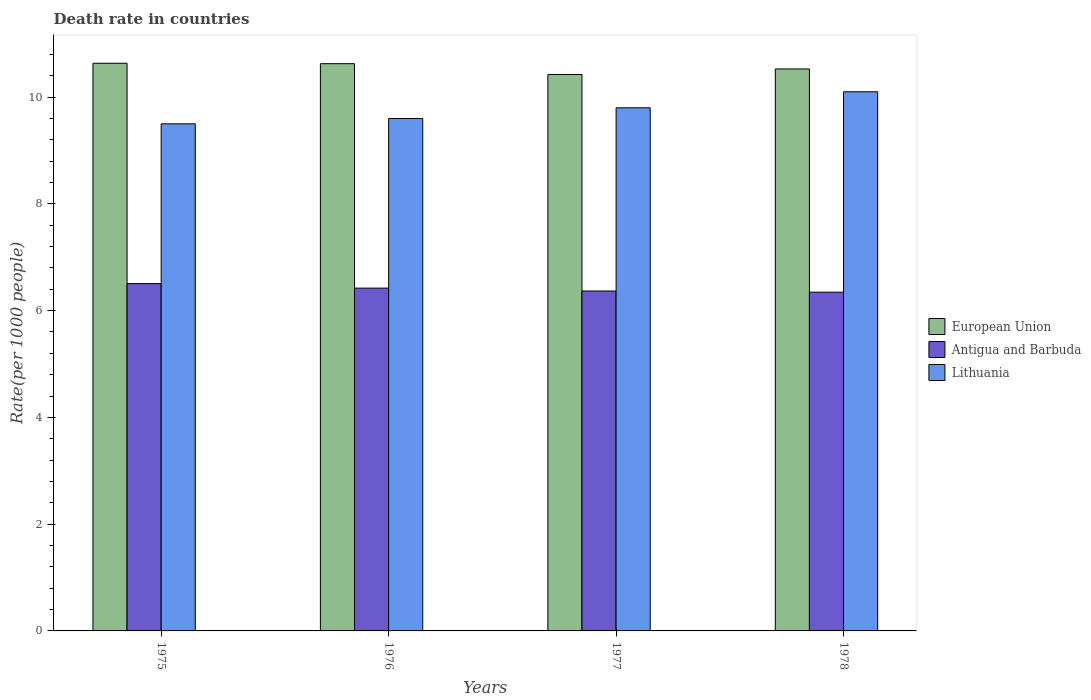How many groups of bars are there?
Provide a short and direct response. 4. Are the number of bars on each tick of the X-axis equal?
Keep it short and to the point. Yes. What is the label of the 4th group of bars from the left?
Provide a short and direct response. 1978. In how many cases, is the number of bars for a given year not equal to the number of legend labels?
Provide a short and direct response. 0. What is the death rate in Antigua and Barbuda in 1976?
Your response must be concise. 6.42. Across all years, what is the minimum death rate in Antigua and Barbuda?
Make the answer very short. 6.35. In which year was the death rate in Lithuania maximum?
Provide a short and direct response. 1978. In which year was the death rate in Lithuania minimum?
Make the answer very short. 1975. What is the total death rate in European Union in the graph?
Give a very brief answer. 42.21. What is the difference between the death rate in Antigua and Barbuda in 1976 and that in 1977?
Make the answer very short. 0.05. What is the difference between the death rate in Lithuania in 1976 and the death rate in Antigua and Barbuda in 1978?
Provide a succinct answer. 3.25. What is the average death rate in Lithuania per year?
Your answer should be compact. 9.75. In the year 1978, what is the difference between the death rate in Antigua and Barbuda and death rate in European Union?
Ensure brevity in your answer.  -4.18. In how many years, is the death rate in European Union greater than 8.8?
Keep it short and to the point. 4. What is the ratio of the death rate in European Union in 1975 to that in 1977?
Ensure brevity in your answer.  1.02. Is the death rate in European Union in 1976 less than that in 1977?
Provide a short and direct response. No. What is the difference between the highest and the second highest death rate in Lithuania?
Provide a succinct answer. 0.3. What is the difference between the highest and the lowest death rate in Lithuania?
Make the answer very short. 0.6. Is the sum of the death rate in Antigua and Barbuda in 1976 and 1978 greater than the maximum death rate in European Union across all years?
Make the answer very short. Yes. What does the 3rd bar from the left in 1977 represents?
Offer a very short reply. Lithuania. What does the 3rd bar from the right in 1976 represents?
Ensure brevity in your answer.  European Union. How many bars are there?
Give a very brief answer. 12. Are all the bars in the graph horizontal?
Offer a very short reply. No. How many years are there in the graph?
Provide a succinct answer. 4. What is the difference between two consecutive major ticks on the Y-axis?
Make the answer very short. 2. How many legend labels are there?
Your answer should be very brief. 3. How are the legend labels stacked?
Ensure brevity in your answer.  Vertical. What is the title of the graph?
Your answer should be very brief. Death rate in countries. Does "High income: nonOECD" appear as one of the legend labels in the graph?
Keep it short and to the point. No. What is the label or title of the X-axis?
Ensure brevity in your answer.  Years. What is the label or title of the Y-axis?
Your answer should be very brief. Rate(per 1000 people). What is the Rate(per 1000 people) in European Union in 1975?
Your answer should be compact. 10.63. What is the Rate(per 1000 people) of Antigua and Barbuda in 1975?
Ensure brevity in your answer.  6.51. What is the Rate(per 1000 people) of Lithuania in 1975?
Your response must be concise. 9.5. What is the Rate(per 1000 people) in European Union in 1976?
Keep it short and to the point. 10.63. What is the Rate(per 1000 people) in Antigua and Barbuda in 1976?
Ensure brevity in your answer.  6.42. What is the Rate(per 1000 people) in European Union in 1977?
Keep it short and to the point. 10.42. What is the Rate(per 1000 people) of Antigua and Barbuda in 1977?
Provide a succinct answer. 6.37. What is the Rate(per 1000 people) of European Union in 1978?
Offer a very short reply. 10.53. What is the Rate(per 1000 people) of Antigua and Barbuda in 1978?
Offer a very short reply. 6.35. Across all years, what is the maximum Rate(per 1000 people) of European Union?
Offer a very short reply. 10.63. Across all years, what is the maximum Rate(per 1000 people) of Antigua and Barbuda?
Keep it short and to the point. 6.51. Across all years, what is the minimum Rate(per 1000 people) in European Union?
Your answer should be compact. 10.42. Across all years, what is the minimum Rate(per 1000 people) of Antigua and Barbuda?
Ensure brevity in your answer.  6.35. What is the total Rate(per 1000 people) of European Union in the graph?
Ensure brevity in your answer.  42.21. What is the total Rate(per 1000 people) of Antigua and Barbuda in the graph?
Provide a short and direct response. 25.64. What is the difference between the Rate(per 1000 people) in European Union in 1975 and that in 1976?
Give a very brief answer. 0.01. What is the difference between the Rate(per 1000 people) of Antigua and Barbuda in 1975 and that in 1976?
Your response must be concise. 0.09. What is the difference between the Rate(per 1000 people) in European Union in 1975 and that in 1977?
Offer a terse response. 0.21. What is the difference between the Rate(per 1000 people) of Antigua and Barbuda in 1975 and that in 1977?
Your answer should be compact. 0.14. What is the difference between the Rate(per 1000 people) in European Union in 1975 and that in 1978?
Offer a terse response. 0.11. What is the difference between the Rate(per 1000 people) of Antigua and Barbuda in 1975 and that in 1978?
Your response must be concise. 0.16. What is the difference between the Rate(per 1000 people) of Lithuania in 1975 and that in 1978?
Your response must be concise. -0.6. What is the difference between the Rate(per 1000 people) in European Union in 1976 and that in 1977?
Your response must be concise. 0.2. What is the difference between the Rate(per 1000 people) in Antigua and Barbuda in 1976 and that in 1977?
Your answer should be very brief. 0.05. What is the difference between the Rate(per 1000 people) in Lithuania in 1976 and that in 1977?
Your answer should be compact. -0.2. What is the difference between the Rate(per 1000 people) of European Union in 1976 and that in 1978?
Your answer should be very brief. 0.1. What is the difference between the Rate(per 1000 people) in Antigua and Barbuda in 1976 and that in 1978?
Provide a succinct answer. 0.08. What is the difference between the Rate(per 1000 people) in Lithuania in 1976 and that in 1978?
Give a very brief answer. -0.5. What is the difference between the Rate(per 1000 people) of European Union in 1977 and that in 1978?
Provide a short and direct response. -0.1. What is the difference between the Rate(per 1000 people) of Antigua and Barbuda in 1977 and that in 1978?
Your answer should be very brief. 0.02. What is the difference between the Rate(per 1000 people) of Lithuania in 1977 and that in 1978?
Offer a terse response. -0.3. What is the difference between the Rate(per 1000 people) of European Union in 1975 and the Rate(per 1000 people) of Antigua and Barbuda in 1976?
Provide a short and direct response. 4.21. What is the difference between the Rate(per 1000 people) of European Union in 1975 and the Rate(per 1000 people) of Lithuania in 1976?
Provide a succinct answer. 1.03. What is the difference between the Rate(per 1000 people) of Antigua and Barbuda in 1975 and the Rate(per 1000 people) of Lithuania in 1976?
Keep it short and to the point. -3.09. What is the difference between the Rate(per 1000 people) in European Union in 1975 and the Rate(per 1000 people) in Antigua and Barbuda in 1977?
Your answer should be compact. 4.27. What is the difference between the Rate(per 1000 people) in European Union in 1975 and the Rate(per 1000 people) in Lithuania in 1977?
Offer a very short reply. 0.83. What is the difference between the Rate(per 1000 people) of Antigua and Barbuda in 1975 and the Rate(per 1000 people) of Lithuania in 1977?
Ensure brevity in your answer.  -3.29. What is the difference between the Rate(per 1000 people) of European Union in 1975 and the Rate(per 1000 people) of Antigua and Barbuda in 1978?
Your answer should be compact. 4.29. What is the difference between the Rate(per 1000 people) of European Union in 1975 and the Rate(per 1000 people) of Lithuania in 1978?
Give a very brief answer. 0.53. What is the difference between the Rate(per 1000 people) of Antigua and Barbuda in 1975 and the Rate(per 1000 people) of Lithuania in 1978?
Offer a very short reply. -3.59. What is the difference between the Rate(per 1000 people) in European Union in 1976 and the Rate(per 1000 people) in Antigua and Barbuda in 1977?
Provide a succinct answer. 4.26. What is the difference between the Rate(per 1000 people) in European Union in 1976 and the Rate(per 1000 people) in Lithuania in 1977?
Your response must be concise. 0.83. What is the difference between the Rate(per 1000 people) of Antigua and Barbuda in 1976 and the Rate(per 1000 people) of Lithuania in 1977?
Make the answer very short. -3.38. What is the difference between the Rate(per 1000 people) in European Union in 1976 and the Rate(per 1000 people) in Antigua and Barbuda in 1978?
Make the answer very short. 4.28. What is the difference between the Rate(per 1000 people) in European Union in 1976 and the Rate(per 1000 people) in Lithuania in 1978?
Your response must be concise. 0.53. What is the difference between the Rate(per 1000 people) of Antigua and Barbuda in 1976 and the Rate(per 1000 people) of Lithuania in 1978?
Offer a very short reply. -3.68. What is the difference between the Rate(per 1000 people) of European Union in 1977 and the Rate(per 1000 people) of Antigua and Barbuda in 1978?
Keep it short and to the point. 4.08. What is the difference between the Rate(per 1000 people) in European Union in 1977 and the Rate(per 1000 people) in Lithuania in 1978?
Provide a succinct answer. 0.32. What is the difference between the Rate(per 1000 people) of Antigua and Barbuda in 1977 and the Rate(per 1000 people) of Lithuania in 1978?
Ensure brevity in your answer.  -3.73. What is the average Rate(per 1000 people) of European Union per year?
Make the answer very short. 10.55. What is the average Rate(per 1000 people) in Antigua and Barbuda per year?
Give a very brief answer. 6.41. What is the average Rate(per 1000 people) in Lithuania per year?
Make the answer very short. 9.75. In the year 1975, what is the difference between the Rate(per 1000 people) in European Union and Rate(per 1000 people) in Antigua and Barbuda?
Ensure brevity in your answer.  4.13. In the year 1975, what is the difference between the Rate(per 1000 people) of European Union and Rate(per 1000 people) of Lithuania?
Provide a succinct answer. 1.13. In the year 1975, what is the difference between the Rate(per 1000 people) in Antigua and Barbuda and Rate(per 1000 people) in Lithuania?
Make the answer very short. -2.99. In the year 1976, what is the difference between the Rate(per 1000 people) of European Union and Rate(per 1000 people) of Antigua and Barbuda?
Offer a terse response. 4.2. In the year 1976, what is the difference between the Rate(per 1000 people) of European Union and Rate(per 1000 people) of Lithuania?
Provide a succinct answer. 1.03. In the year 1976, what is the difference between the Rate(per 1000 people) of Antigua and Barbuda and Rate(per 1000 people) of Lithuania?
Your response must be concise. -3.18. In the year 1977, what is the difference between the Rate(per 1000 people) of European Union and Rate(per 1000 people) of Antigua and Barbuda?
Provide a short and direct response. 4.06. In the year 1977, what is the difference between the Rate(per 1000 people) in European Union and Rate(per 1000 people) in Lithuania?
Keep it short and to the point. 0.62. In the year 1977, what is the difference between the Rate(per 1000 people) of Antigua and Barbuda and Rate(per 1000 people) of Lithuania?
Your response must be concise. -3.43. In the year 1978, what is the difference between the Rate(per 1000 people) in European Union and Rate(per 1000 people) in Antigua and Barbuda?
Provide a short and direct response. 4.18. In the year 1978, what is the difference between the Rate(per 1000 people) of European Union and Rate(per 1000 people) of Lithuania?
Your answer should be compact. 0.43. In the year 1978, what is the difference between the Rate(per 1000 people) of Antigua and Barbuda and Rate(per 1000 people) of Lithuania?
Your answer should be compact. -3.75. What is the ratio of the Rate(per 1000 people) of Antigua and Barbuda in 1975 to that in 1976?
Give a very brief answer. 1.01. What is the ratio of the Rate(per 1000 people) of Lithuania in 1975 to that in 1976?
Provide a short and direct response. 0.99. What is the ratio of the Rate(per 1000 people) of European Union in 1975 to that in 1977?
Your answer should be compact. 1.02. What is the ratio of the Rate(per 1000 people) in Antigua and Barbuda in 1975 to that in 1977?
Your answer should be compact. 1.02. What is the ratio of the Rate(per 1000 people) in Lithuania in 1975 to that in 1977?
Ensure brevity in your answer.  0.97. What is the ratio of the Rate(per 1000 people) of Antigua and Barbuda in 1975 to that in 1978?
Keep it short and to the point. 1.03. What is the ratio of the Rate(per 1000 people) in Lithuania in 1975 to that in 1978?
Give a very brief answer. 0.94. What is the ratio of the Rate(per 1000 people) of European Union in 1976 to that in 1977?
Provide a short and direct response. 1.02. What is the ratio of the Rate(per 1000 people) in Antigua and Barbuda in 1976 to that in 1977?
Provide a short and direct response. 1.01. What is the ratio of the Rate(per 1000 people) of Lithuania in 1976 to that in 1977?
Your answer should be very brief. 0.98. What is the ratio of the Rate(per 1000 people) of European Union in 1976 to that in 1978?
Your answer should be very brief. 1.01. What is the ratio of the Rate(per 1000 people) of Antigua and Barbuda in 1976 to that in 1978?
Your response must be concise. 1.01. What is the ratio of the Rate(per 1000 people) in Lithuania in 1976 to that in 1978?
Offer a very short reply. 0.95. What is the ratio of the Rate(per 1000 people) in Lithuania in 1977 to that in 1978?
Offer a terse response. 0.97. What is the difference between the highest and the second highest Rate(per 1000 people) in European Union?
Your answer should be compact. 0.01. What is the difference between the highest and the second highest Rate(per 1000 people) of Antigua and Barbuda?
Offer a terse response. 0.09. What is the difference between the highest and the lowest Rate(per 1000 people) of European Union?
Provide a short and direct response. 0.21. What is the difference between the highest and the lowest Rate(per 1000 people) of Antigua and Barbuda?
Make the answer very short. 0.16. What is the difference between the highest and the lowest Rate(per 1000 people) of Lithuania?
Provide a short and direct response. 0.6. 